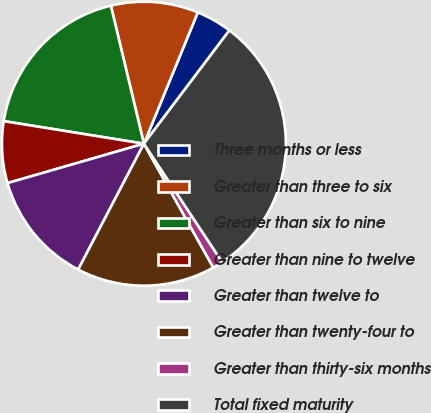Convert chart to OTSL. <chart><loc_0><loc_0><loc_500><loc_500><pie_chart><fcel>Three months or less<fcel>Greater than three to six<fcel>Greater than six to nine<fcel>Greater than nine to twelve<fcel>Greater than twelve to<fcel>Greater than twenty-four to<fcel>Greater than thirty-six months<fcel>Total fixed maturity<nl><fcel>4.09%<fcel>9.94%<fcel>18.72%<fcel>7.02%<fcel>12.87%<fcel>15.79%<fcel>1.17%<fcel>30.42%<nl></chart> 